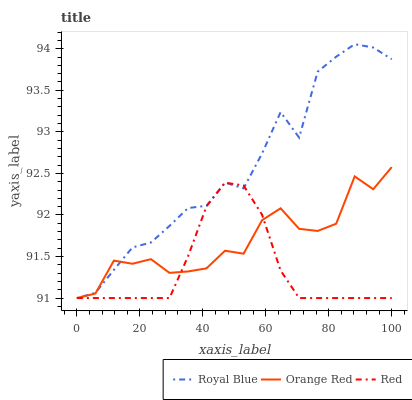Does Orange Red have the minimum area under the curve?
Answer yes or no. No. Does Orange Red have the maximum area under the curve?
Answer yes or no. No. Is Orange Red the smoothest?
Answer yes or no. No. Is Orange Red the roughest?
Answer yes or no. No. Does Orange Red have the highest value?
Answer yes or no. No. 